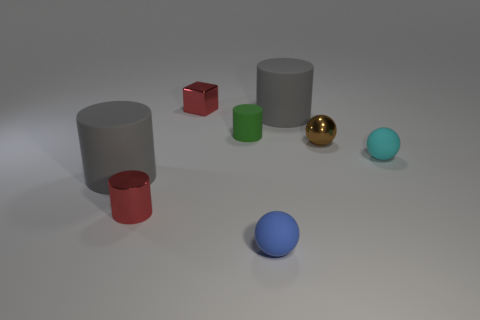Add 1 red things. How many objects exist? 9 Subtract all cubes. How many objects are left? 7 Subtract all large rubber things. Subtract all tiny brown metal things. How many objects are left? 5 Add 8 brown metallic objects. How many brown metallic objects are left? 9 Add 8 tiny green cylinders. How many tiny green cylinders exist? 9 Subtract 0 blue cylinders. How many objects are left? 8 